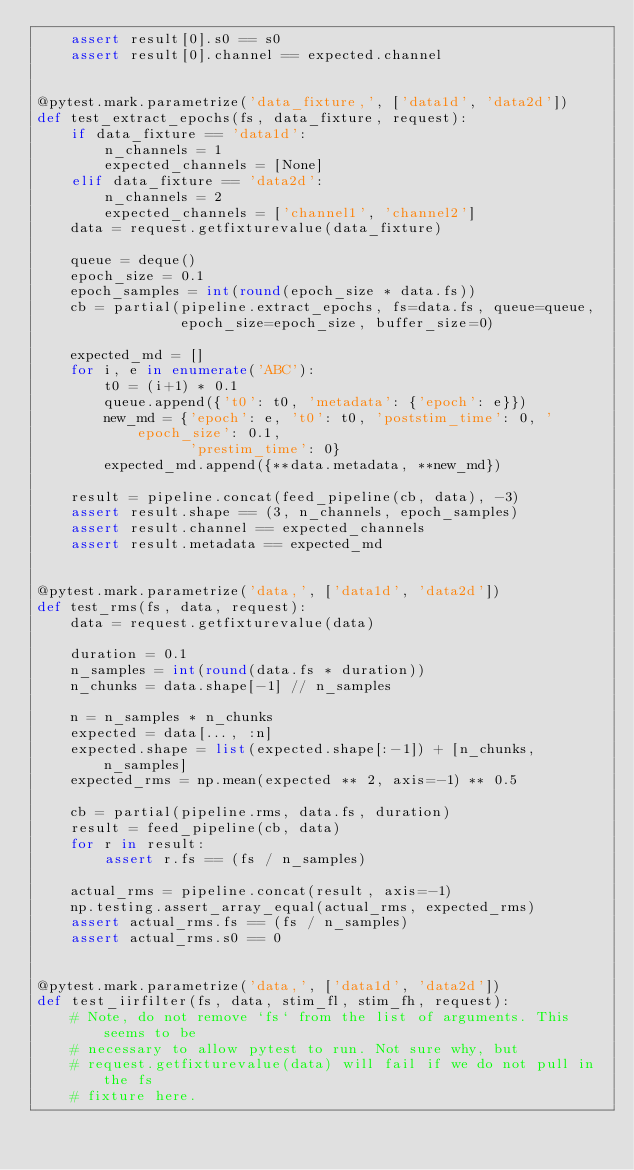<code> <loc_0><loc_0><loc_500><loc_500><_Python_>    assert result[0].s0 == s0
    assert result[0].channel == expected.channel


@pytest.mark.parametrize('data_fixture,', ['data1d', 'data2d'])
def test_extract_epochs(fs, data_fixture, request):
    if data_fixture == 'data1d':
        n_channels = 1
        expected_channels = [None]
    elif data_fixture == 'data2d':
        n_channels = 2
        expected_channels = ['channel1', 'channel2']
    data = request.getfixturevalue(data_fixture)

    queue = deque()
    epoch_size = 0.1
    epoch_samples = int(round(epoch_size * data.fs))
    cb = partial(pipeline.extract_epochs, fs=data.fs, queue=queue,
                 epoch_size=epoch_size, buffer_size=0)

    expected_md = []
    for i, e in enumerate('ABC'):
        t0 = (i+1) * 0.1
        queue.append({'t0': t0, 'metadata': {'epoch': e}})
        new_md = {'epoch': e, 't0': t0, 'poststim_time': 0, 'epoch_size': 0.1,
                  'prestim_time': 0}
        expected_md.append({**data.metadata, **new_md})

    result = pipeline.concat(feed_pipeline(cb, data), -3)
    assert result.shape == (3, n_channels, epoch_samples)
    assert result.channel == expected_channels
    assert result.metadata == expected_md


@pytest.mark.parametrize('data,', ['data1d', 'data2d'])
def test_rms(fs, data, request):
    data = request.getfixturevalue(data)

    duration = 0.1
    n_samples = int(round(data.fs * duration))
    n_chunks = data.shape[-1] // n_samples

    n = n_samples * n_chunks
    expected = data[..., :n]
    expected.shape = list(expected.shape[:-1]) + [n_chunks, n_samples]
    expected_rms = np.mean(expected ** 2, axis=-1) ** 0.5

    cb = partial(pipeline.rms, data.fs, duration)
    result = feed_pipeline(cb, data)
    for r in result:
        assert r.fs == (fs / n_samples)

    actual_rms = pipeline.concat(result, axis=-1)
    np.testing.assert_array_equal(actual_rms, expected_rms)
    assert actual_rms.fs == (fs / n_samples)
    assert actual_rms.s0 == 0


@pytest.mark.parametrize('data,', ['data1d', 'data2d'])
def test_iirfilter(fs, data, stim_fl, stim_fh, request):
    # Note, do not remove `fs` from the list of arguments. This seems to be
    # necessary to allow pytest to run. Not sure why, but
    # request.getfixturevalue(data) will fail if we do not pull in the fs
    # fixture here.</code> 